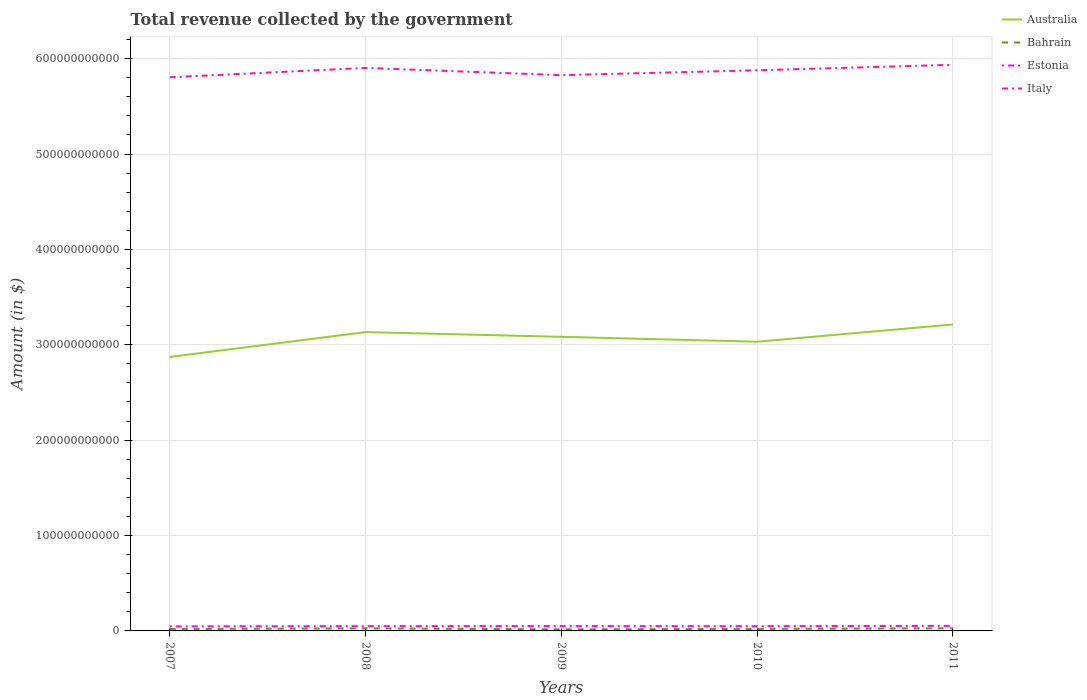Across all years, what is the maximum total revenue collected by the government in Italy?
Offer a very short reply. 5.80e+11. In which year was the total revenue collected by the government in Australia maximum?
Your answer should be compact. 2007. What is the total total revenue collected by the government in Australia in the graph?
Give a very brief answer. -1.60e+1. What is the difference between the highest and the second highest total revenue collected by the government in Estonia?
Keep it short and to the point. 5.53e+08. Is the total revenue collected by the government in Italy strictly greater than the total revenue collected by the government in Estonia over the years?
Provide a succinct answer. No. How many years are there in the graph?
Give a very brief answer. 5. What is the difference between two consecutive major ticks on the Y-axis?
Your response must be concise. 1.00e+11. Are the values on the major ticks of Y-axis written in scientific E-notation?
Provide a short and direct response. No. Does the graph contain grids?
Offer a terse response. Yes. How are the legend labels stacked?
Your answer should be very brief. Vertical. What is the title of the graph?
Your answer should be compact. Total revenue collected by the government. Does "San Marino" appear as one of the legend labels in the graph?
Your answer should be very brief. No. What is the label or title of the Y-axis?
Offer a terse response. Amount (in $). What is the Amount (in $) of Australia in 2007?
Give a very brief answer. 2.87e+11. What is the Amount (in $) of Bahrain in 2007?
Make the answer very short. 2.00e+09. What is the Amount (in $) in Estonia in 2007?
Keep it short and to the point. 4.76e+09. What is the Amount (in $) in Italy in 2007?
Provide a short and direct response. 5.80e+11. What is the Amount (in $) in Australia in 2008?
Make the answer very short. 3.13e+11. What is the Amount (in $) of Bahrain in 2008?
Offer a terse response. 2.65e+09. What is the Amount (in $) of Estonia in 2008?
Your answer should be compact. 4.98e+09. What is the Amount (in $) in Italy in 2008?
Offer a terse response. 5.90e+11. What is the Amount (in $) of Australia in 2009?
Offer a very short reply. 3.08e+11. What is the Amount (in $) of Bahrain in 2009?
Provide a succinct answer. 1.68e+09. What is the Amount (in $) in Estonia in 2009?
Provide a succinct answer. 5.06e+09. What is the Amount (in $) in Italy in 2009?
Your answer should be compact. 5.83e+11. What is the Amount (in $) of Australia in 2010?
Your response must be concise. 3.03e+11. What is the Amount (in $) of Bahrain in 2010?
Your response must be concise. 2.15e+09. What is the Amount (in $) of Estonia in 2010?
Provide a short and direct response. 4.96e+09. What is the Amount (in $) in Italy in 2010?
Offer a very short reply. 5.88e+11. What is the Amount (in $) in Australia in 2011?
Your answer should be compact. 3.21e+11. What is the Amount (in $) of Bahrain in 2011?
Your response must be concise. 2.72e+09. What is the Amount (in $) of Estonia in 2011?
Offer a terse response. 5.31e+09. What is the Amount (in $) of Italy in 2011?
Provide a short and direct response. 5.94e+11. Across all years, what is the maximum Amount (in $) in Australia?
Your response must be concise. 3.21e+11. Across all years, what is the maximum Amount (in $) in Bahrain?
Provide a short and direct response. 2.72e+09. Across all years, what is the maximum Amount (in $) in Estonia?
Your response must be concise. 5.31e+09. Across all years, what is the maximum Amount (in $) of Italy?
Offer a very short reply. 5.94e+11. Across all years, what is the minimum Amount (in $) of Australia?
Make the answer very short. 2.87e+11. Across all years, what is the minimum Amount (in $) in Bahrain?
Your response must be concise. 1.68e+09. Across all years, what is the minimum Amount (in $) of Estonia?
Your response must be concise. 4.76e+09. Across all years, what is the minimum Amount (in $) in Italy?
Offer a very short reply. 5.80e+11. What is the total Amount (in $) in Australia in the graph?
Ensure brevity in your answer.  1.53e+12. What is the total Amount (in $) in Bahrain in the graph?
Give a very brief answer. 1.12e+1. What is the total Amount (in $) in Estonia in the graph?
Provide a succinct answer. 2.51e+1. What is the total Amount (in $) of Italy in the graph?
Your answer should be very brief. 2.93e+12. What is the difference between the Amount (in $) of Australia in 2007 and that in 2008?
Make the answer very short. -2.61e+1. What is the difference between the Amount (in $) in Bahrain in 2007 and that in 2008?
Give a very brief answer. -6.47e+08. What is the difference between the Amount (in $) of Estonia in 2007 and that in 2008?
Give a very brief answer. -2.25e+08. What is the difference between the Amount (in $) of Italy in 2007 and that in 2008?
Your answer should be compact. -9.86e+09. What is the difference between the Amount (in $) of Australia in 2007 and that in 2009?
Ensure brevity in your answer.  -2.12e+1. What is the difference between the Amount (in $) in Bahrain in 2007 and that in 2009?
Make the answer very short. 3.21e+08. What is the difference between the Amount (in $) of Estonia in 2007 and that in 2009?
Your response must be concise. -3.03e+08. What is the difference between the Amount (in $) in Italy in 2007 and that in 2009?
Give a very brief answer. -2.27e+09. What is the difference between the Amount (in $) in Australia in 2007 and that in 2010?
Provide a succinct answer. -1.60e+1. What is the difference between the Amount (in $) in Bahrain in 2007 and that in 2010?
Make the answer very short. -1.46e+08. What is the difference between the Amount (in $) in Estonia in 2007 and that in 2010?
Give a very brief answer. -1.97e+08. What is the difference between the Amount (in $) of Italy in 2007 and that in 2010?
Offer a very short reply. -7.37e+09. What is the difference between the Amount (in $) in Australia in 2007 and that in 2011?
Your response must be concise. -3.41e+1. What is the difference between the Amount (in $) of Bahrain in 2007 and that in 2011?
Keep it short and to the point. -7.18e+08. What is the difference between the Amount (in $) in Estonia in 2007 and that in 2011?
Provide a succinct answer. -5.53e+08. What is the difference between the Amount (in $) in Italy in 2007 and that in 2011?
Provide a succinct answer. -1.31e+1. What is the difference between the Amount (in $) in Australia in 2008 and that in 2009?
Your answer should be compact. 4.94e+09. What is the difference between the Amount (in $) of Bahrain in 2008 and that in 2009?
Your answer should be compact. 9.69e+08. What is the difference between the Amount (in $) in Estonia in 2008 and that in 2009?
Your answer should be compact. -7.78e+07. What is the difference between the Amount (in $) in Italy in 2008 and that in 2009?
Give a very brief answer. 7.59e+09. What is the difference between the Amount (in $) of Australia in 2008 and that in 2010?
Your response must be concise. 1.01e+1. What is the difference between the Amount (in $) in Bahrain in 2008 and that in 2010?
Give a very brief answer. 5.01e+08. What is the difference between the Amount (in $) in Estonia in 2008 and that in 2010?
Provide a succinct answer. 2.82e+07. What is the difference between the Amount (in $) of Italy in 2008 and that in 2010?
Offer a very short reply. 2.49e+09. What is the difference between the Amount (in $) in Australia in 2008 and that in 2011?
Provide a short and direct response. -7.99e+09. What is the difference between the Amount (in $) of Bahrain in 2008 and that in 2011?
Provide a succinct answer. -7.10e+07. What is the difference between the Amount (in $) of Estonia in 2008 and that in 2011?
Make the answer very short. -3.28e+08. What is the difference between the Amount (in $) in Italy in 2008 and that in 2011?
Keep it short and to the point. -3.27e+09. What is the difference between the Amount (in $) of Australia in 2009 and that in 2010?
Make the answer very short. 5.14e+09. What is the difference between the Amount (in $) of Bahrain in 2009 and that in 2010?
Your answer should be compact. -4.67e+08. What is the difference between the Amount (in $) in Estonia in 2009 and that in 2010?
Your answer should be very brief. 1.06e+08. What is the difference between the Amount (in $) in Italy in 2009 and that in 2010?
Your response must be concise. -5.10e+09. What is the difference between the Amount (in $) of Australia in 2009 and that in 2011?
Ensure brevity in your answer.  -1.29e+1. What is the difference between the Amount (in $) in Bahrain in 2009 and that in 2011?
Your response must be concise. -1.04e+09. What is the difference between the Amount (in $) of Estonia in 2009 and that in 2011?
Ensure brevity in your answer.  -2.50e+08. What is the difference between the Amount (in $) of Italy in 2009 and that in 2011?
Offer a terse response. -1.09e+1. What is the difference between the Amount (in $) of Australia in 2010 and that in 2011?
Offer a terse response. -1.81e+1. What is the difference between the Amount (in $) in Bahrain in 2010 and that in 2011?
Your response must be concise. -5.72e+08. What is the difference between the Amount (in $) in Estonia in 2010 and that in 2011?
Keep it short and to the point. -3.56e+08. What is the difference between the Amount (in $) of Italy in 2010 and that in 2011?
Offer a very short reply. -5.75e+09. What is the difference between the Amount (in $) in Australia in 2007 and the Amount (in $) in Bahrain in 2008?
Your answer should be very brief. 2.85e+11. What is the difference between the Amount (in $) in Australia in 2007 and the Amount (in $) in Estonia in 2008?
Provide a short and direct response. 2.82e+11. What is the difference between the Amount (in $) of Australia in 2007 and the Amount (in $) of Italy in 2008?
Keep it short and to the point. -3.03e+11. What is the difference between the Amount (in $) of Bahrain in 2007 and the Amount (in $) of Estonia in 2008?
Your response must be concise. -2.98e+09. What is the difference between the Amount (in $) in Bahrain in 2007 and the Amount (in $) in Italy in 2008?
Provide a succinct answer. -5.88e+11. What is the difference between the Amount (in $) in Estonia in 2007 and the Amount (in $) in Italy in 2008?
Give a very brief answer. -5.85e+11. What is the difference between the Amount (in $) of Australia in 2007 and the Amount (in $) of Bahrain in 2009?
Offer a very short reply. 2.86e+11. What is the difference between the Amount (in $) of Australia in 2007 and the Amount (in $) of Estonia in 2009?
Provide a short and direct response. 2.82e+11. What is the difference between the Amount (in $) of Australia in 2007 and the Amount (in $) of Italy in 2009?
Give a very brief answer. -2.95e+11. What is the difference between the Amount (in $) of Bahrain in 2007 and the Amount (in $) of Estonia in 2009?
Your answer should be compact. -3.06e+09. What is the difference between the Amount (in $) of Bahrain in 2007 and the Amount (in $) of Italy in 2009?
Your answer should be compact. -5.81e+11. What is the difference between the Amount (in $) in Estonia in 2007 and the Amount (in $) in Italy in 2009?
Your answer should be compact. -5.78e+11. What is the difference between the Amount (in $) of Australia in 2007 and the Amount (in $) of Bahrain in 2010?
Your response must be concise. 2.85e+11. What is the difference between the Amount (in $) of Australia in 2007 and the Amount (in $) of Estonia in 2010?
Your answer should be very brief. 2.82e+11. What is the difference between the Amount (in $) of Australia in 2007 and the Amount (in $) of Italy in 2010?
Provide a succinct answer. -3.01e+11. What is the difference between the Amount (in $) in Bahrain in 2007 and the Amount (in $) in Estonia in 2010?
Your answer should be very brief. -2.96e+09. What is the difference between the Amount (in $) of Bahrain in 2007 and the Amount (in $) of Italy in 2010?
Keep it short and to the point. -5.86e+11. What is the difference between the Amount (in $) in Estonia in 2007 and the Amount (in $) in Italy in 2010?
Keep it short and to the point. -5.83e+11. What is the difference between the Amount (in $) in Australia in 2007 and the Amount (in $) in Bahrain in 2011?
Your answer should be compact. 2.84e+11. What is the difference between the Amount (in $) in Australia in 2007 and the Amount (in $) in Estonia in 2011?
Keep it short and to the point. 2.82e+11. What is the difference between the Amount (in $) of Australia in 2007 and the Amount (in $) of Italy in 2011?
Your answer should be compact. -3.06e+11. What is the difference between the Amount (in $) of Bahrain in 2007 and the Amount (in $) of Estonia in 2011?
Your response must be concise. -3.31e+09. What is the difference between the Amount (in $) of Bahrain in 2007 and the Amount (in $) of Italy in 2011?
Offer a very short reply. -5.92e+11. What is the difference between the Amount (in $) of Estonia in 2007 and the Amount (in $) of Italy in 2011?
Your response must be concise. -5.89e+11. What is the difference between the Amount (in $) of Australia in 2008 and the Amount (in $) of Bahrain in 2009?
Your response must be concise. 3.12e+11. What is the difference between the Amount (in $) in Australia in 2008 and the Amount (in $) in Estonia in 2009?
Keep it short and to the point. 3.08e+11. What is the difference between the Amount (in $) of Australia in 2008 and the Amount (in $) of Italy in 2009?
Make the answer very short. -2.69e+11. What is the difference between the Amount (in $) in Bahrain in 2008 and the Amount (in $) in Estonia in 2009?
Give a very brief answer. -2.41e+09. What is the difference between the Amount (in $) of Bahrain in 2008 and the Amount (in $) of Italy in 2009?
Make the answer very short. -5.80e+11. What is the difference between the Amount (in $) of Estonia in 2008 and the Amount (in $) of Italy in 2009?
Give a very brief answer. -5.78e+11. What is the difference between the Amount (in $) of Australia in 2008 and the Amount (in $) of Bahrain in 2010?
Your response must be concise. 3.11e+11. What is the difference between the Amount (in $) in Australia in 2008 and the Amount (in $) in Estonia in 2010?
Keep it short and to the point. 3.08e+11. What is the difference between the Amount (in $) in Australia in 2008 and the Amount (in $) in Italy in 2010?
Offer a terse response. -2.74e+11. What is the difference between the Amount (in $) of Bahrain in 2008 and the Amount (in $) of Estonia in 2010?
Ensure brevity in your answer.  -2.31e+09. What is the difference between the Amount (in $) of Bahrain in 2008 and the Amount (in $) of Italy in 2010?
Keep it short and to the point. -5.85e+11. What is the difference between the Amount (in $) of Estonia in 2008 and the Amount (in $) of Italy in 2010?
Make the answer very short. -5.83e+11. What is the difference between the Amount (in $) of Australia in 2008 and the Amount (in $) of Bahrain in 2011?
Give a very brief answer. 3.11e+11. What is the difference between the Amount (in $) of Australia in 2008 and the Amount (in $) of Estonia in 2011?
Offer a very short reply. 3.08e+11. What is the difference between the Amount (in $) of Australia in 2008 and the Amount (in $) of Italy in 2011?
Provide a short and direct response. -2.80e+11. What is the difference between the Amount (in $) in Bahrain in 2008 and the Amount (in $) in Estonia in 2011?
Ensure brevity in your answer.  -2.66e+09. What is the difference between the Amount (in $) of Bahrain in 2008 and the Amount (in $) of Italy in 2011?
Your answer should be compact. -5.91e+11. What is the difference between the Amount (in $) of Estonia in 2008 and the Amount (in $) of Italy in 2011?
Provide a succinct answer. -5.89e+11. What is the difference between the Amount (in $) of Australia in 2009 and the Amount (in $) of Bahrain in 2010?
Your response must be concise. 3.06e+11. What is the difference between the Amount (in $) of Australia in 2009 and the Amount (in $) of Estonia in 2010?
Provide a succinct answer. 3.03e+11. What is the difference between the Amount (in $) in Australia in 2009 and the Amount (in $) in Italy in 2010?
Your response must be concise. -2.79e+11. What is the difference between the Amount (in $) in Bahrain in 2009 and the Amount (in $) in Estonia in 2010?
Keep it short and to the point. -3.28e+09. What is the difference between the Amount (in $) of Bahrain in 2009 and the Amount (in $) of Italy in 2010?
Ensure brevity in your answer.  -5.86e+11. What is the difference between the Amount (in $) in Estonia in 2009 and the Amount (in $) in Italy in 2010?
Make the answer very short. -5.83e+11. What is the difference between the Amount (in $) of Australia in 2009 and the Amount (in $) of Bahrain in 2011?
Ensure brevity in your answer.  3.06e+11. What is the difference between the Amount (in $) in Australia in 2009 and the Amount (in $) in Estonia in 2011?
Give a very brief answer. 3.03e+11. What is the difference between the Amount (in $) in Australia in 2009 and the Amount (in $) in Italy in 2011?
Your answer should be compact. -2.85e+11. What is the difference between the Amount (in $) in Bahrain in 2009 and the Amount (in $) in Estonia in 2011?
Offer a very short reply. -3.63e+09. What is the difference between the Amount (in $) in Bahrain in 2009 and the Amount (in $) in Italy in 2011?
Provide a short and direct response. -5.92e+11. What is the difference between the Amount (in $) of Estonia in 2009 and the Amount (in $) of Italy in 2011?
Give a very brief answer. -5.88e+11. What is the difference between the Amount (in $) of Australia in 2010 and the Amount (in $) of Bahrain in 2011?
Give a very brief answer. 3.00e+11. What is the difference between the Amount (in $) of Australia in 2010 and the Amount (in $) of Estonia in 2011?
Provide a short and direct response. 2.98e+11. What is the difference between the Amount (in $) of Australia in 2010 and the Amount (in $) of Italy in 2011?
Ensure brevity in your answer.  -2.90e+11. What is the difference between the Amount (in $) in Bahrain in 2010 and the Amount (in $) in Estonia in 2011?
Provide a short and direct response. -3.17e+09. What is the difference between the Amount (in $) of Bahrain in 2010 and the Amount (in $) of Italy in 2011?
Your response must be concise. -5.91e+11. What is the difference between the Amount (in $) of Estonia in 2010 and the Amount (in $) of Italy in 2011?
Provide a succinct answer. -5.89e+11. What is the average Amount (in $) in Australia per year?
Your response must be concise. 3.07e+11. What is the average Amount (in $) of Bahrain per year?
Make the answer very short. 2.24e+09. What is the average Amount (in $) in Estonia per year?
Keep it short and to the point. 5.02e+09. What is the average Amount (in $) in Italy per year?
Your answer should be compact. 5.87e+11. In the year 2007, what is the difference between the Amount (in $) of Australia and Amount (in $) of Bahrain?
Make the answer very short. 2.85e+11. In the year 2007, what is the difference between the Amount (in $) of Australia and Amount (in $) of Estonia?
Your answer should be very brief. 2.82e+11. In the year 2007, what is the difference between the Amount (in $) in Australia and Amount (in $) in Italy?
Ensure brevity in your answer.  -2.93e+11. In the year 2007, what is the difference between the Amount (in $) of Bahrain and Amount (in $) of Estonia?
Provide a short and direct response. -2.76e+09. In the year 2007, what is the difference between the Amount (in $) of Bahrain and Amount (in $) of Italy?
Your response must be concise. -5.78e+11. In the year 2007, what is the difference between the Amount (in $) of Estonia and Amount (in $) of Italy?
Offer a very short reply. -5.76e+11. In the year 2008, what is the difference between the Amount (in $) in Australia and Amount (in $) in Bahrain?
Offer a very short reply. 3.11e+11. In the year 2008, what is the difference between the Amount (in $) of Australia and Amount (in $) of Estonia?
Give a very brief answer. 3.08e+11. In the year 2008, what is the difference between the Amount (in $) in Australia and Amount (in $) in Italy?
Make the answer very short. -2.77e+11. In the year 2008, what is the difference between the Amount (in $) of Bahrain and Amount (in $) of Estonia?
Provide a short and direct response. -2.34e+09. In the year 2008, what is the difference between the Amount (in $) in Bahrain and Amount (in $) in Italy?
Your answer should be very brief. -5.88e+11. In the year 2008, what is the difference between the Amount (in $) in Estonia and Amount (in $) in Italy?
Your response must be concise. -5.85e+11. In the year 2009, what is the difference between the Amount (in $) in Australia and Amount (in $) in Bahrain?
Provide a succinct answer. 3.07e+11. In the year 2009, what is the difference between the Amount (in $) in Australia and Amount (in $) in Estonia?
Offer a very short reply. 3.03e+11. In the year 2009, what is the difference between the Amount (in $) in Australia and Amount (in $) in Italy?
Your answer should be very brief. -2.74e+11. In the year 2009, what is the difference between the Amount (in $) of Bahrain and Amount (in $) of Estonia?
Keep it short and to the point. -3.38e+09. In the year 2009, what is the difference between the Amount (in $) of Bahrain and Amount (in $) of Italy?
Offer a terse response. -5.81e+11. In the year 2009, what is the difference between the Amount (in $) of Estonia and Amount (in $) of Italy?
Keep it short and to the point. -5.78e+11. In the year 2010, what is the difference between the Amount (in $) of Australia and Amount (in $) of Bahrain?
Your answer should be very brief. 3.01e+11. In the year 2010, what is the difference between the Amount (in $) of Australia and Amount (in $) of Estonia?
Provide a succinct answer. 2.98e+11. In the year 2010, what is the difference between the Amount (in $) in Australia and Amount (in $) in Italy?
Offer a very short reply. -2.85e+11. In the year 2010, what is the difference between the Amount (in $) in Bahrain and Amount (in $) in Estonia?
Provide a succinct answer. -2.81e+09. In the year 2010, what is the difference between the Amount (in $) of Bahrain and Amount (in $) of Italy?
Provide a short and direct response. -5.86e+11. In the year 2010, what is the difference between the Amount (in $) in Estonia and Amount (in $) in Italy?
Offer a terse response. -5.83e+11. In the year 2011, what is the difference between the Amount (in $) of Australia and Amount (in $) of Bahrain?
Provide a succinct answer. 3.19e+11. In the year 2011, what is the difference between the Amount (in $) in Australia and Amount (in $) in Estonia?
Give a very brief answer. 3.16e+11. In the year 2011, what is the difference between the Amount (in $) in Australia and Amount (in $) in Italy?
Offer a terse response. -2.72e+11. In the year 2011, what is the difference between the Amount (in $) in Bahrain and Amount (in $) in Estonia?
Your answer should be compact. -2.59e+09. In the year 2011, what is the difference between the Amount (in $) in Bahrain and Amount (in $) in Italy?
Ensure brevity in your answer.  -5.91e+11. In the year 2011, what is the difference between the Amount (in $) in Estonia and Amount (in $) in Italy?
Offer a terse response. -5.88e+11. What is the ratio of the Amount (in $) in Australia in 2007 to that in 2008?
Give a very brief answer. 0.92. What is the ratio of the Amount (in $) of Bahrain in 2007 to that in 2008?
Your answer should be very brief. 0.76. What is the ratio of the Amount (in $) in Estonia in 2007 to that in 2008?
Ensure brevity in your answer.  0.95. What is the ratio of the Amount (in $) in Italy in 2007 to that in 2008?
Your answer should be compact. 0.98. What is the ratio of the Amount (in $) of Australia in 2007 to that in 2009?
Offer a very short reply. 0.93. What is the ratio of the Amount (in $) in Bahrain in 2007 to that in 2009?
Provide a short and direct response. 1.19. What is the ratio of the Amount (in $) in Estonia in 2007 to that in 2009?
Provide a short and direct response. 0.94. What is the ratio of the Amount (in $) in Australia in 2007 to that in 2010?
Keep it short and to the point. 0.95. What is the ratio of the Amount (in $) in Bahrain in 2007 to that in 2010?
Keep it short and to the point. 0.93. What is the ratio of the Amount (in $) in Estonia in 2007 to that in 2010?
Ensure brevity in your answer.  0.96. What is the ratio of the Amount (in $) in Italy in 2007 to that in 2010?
Keep it short and to the point. 0.99. What is the ratio of the Amount (in $) in Australia in 2007 to that in 2011?
Provide a succinct answer. 0.89. What is the ratio of the Amount (in $) in Bahrain in 2007 to that in 2011?
Your answer should be very brief. 0.74. What is the ratio of the Amount (in $) in Estonia in 2007 to that in 2011?
Your answer should be very brief. 0.9. What is the ratio of the Amount (in $) of Italy in 2007 to that in 2011?
Ensure brevity in your answer.  0.98. What is the ratio of the Amount (in $) of Australia in 2008 to that in 2009?
Keep it short and to the point. 1.02. What is the ratio of the Amount (in $) in Bahrain in 2008 to that in 2009?
Your answer should be compact. 1.58. What is the ratio of the Amount (in $) in Estonia in 2008 to that in 2009?
Offer a very short reply. 0.98. What is the ratio of the Amount (in $) in Italy in 2008 to that in 2009?
Make the answer very short. 1.01. What is the ratio of the Amount (in $) in Australia in 2008 to that in 2010?
Offer a terse response. 1.03. What is the ratio of the Amount (in $) in Bahrain in 2008 to that in 2010?
Provide a short and direct response. 1.23. What is the ratio of the Amount (in $) of Australia in 2008 to that in 2011?
Provide a short and direct response. 0.98. What is the ratio of the Amount (in $) in Bahrain in 2008 to that in 2011?
Offer a terse response. 0.97. What is the ratio of the Amount (in $) in Estonia in 2008 to that in 2011?
Keep it short and to the point. 0.94. What is the ratio of the Amount (in $) in Australia in 2009 to that in 2010?
Your response must be concise. 1.02. What is the ratio of the Amount (in $) of Bahrain in 2009 to that in 2010?
Provide a succinct answer. 0.78. What is the ratio of the Amount (in $) in Estonia in 2009 to that in 2010?
Keep it short and to the point. 1.02. What is the ratio of the Amount (in $) in Italy in 2009 to that in 2010?
Provide a short and direct response. 0.99. What is the ratio of the Amount (in $) of Australia in 2009 to that in 2011?
Give a very brief answer. 0.96. What is the ratio of the Amount (in $) in Bahrain in 2009 to that in 2011?
Keep it short and to the point. 0.62. What is the ratio of the Amount (in $) in Estonia in 2009 to that in 2011?
Provide a succinct answer. 0.95. What is the ratio of the Amount (in $) of Italy in 2009 to that in 2011?
Provide a short and direct response. 0.98. What is the ratio of the Amount (in $) of Australia in 2010 to that in 2011?
Your answer should be very brief. 0.94. What is the ratio of the Amount (in $) in Bahrain in 2010 to that in 2011?
Offer a very short reply. 0.79. What is the ratio of the Amount (in $) in Estonia in 2010 to that in 2011?
Your answer should be very brief. 0.93. What is the ratio of the Amount (in $) in Italy in 2010 to that in 2011?
Your response must be concise. 0.99. What is the difference between the highest and the second highest Amount (in $) in Australia?
Provide a succinct answer. 7.99e+09. What is the difference between the highest and the second highest Amount (in $) in Bahrain?
Provide a short and direct response. 7.10e+07. What is the difference between the highest and the second highest Amount (in $) of Estonia?
Provide a succinct answer. 2.50e+08. What is the difference between the highest and the second highest Amount (in $) in Italy?
Your response must be concise. 3.27e+09. What is the difference between the highest and the lowest Amount (in $) in Australia?
Ensure brevity in your answer.  3.41e+1. What is the difference between the highest and the lowest Amount (in $) of Bahrain?
Your answer should be very brief. 1.04e+09. What is the difference between the highest and the lowest Amount (in $) of Estonia?
Your answer should be very brief. 5.53e+08. What is the difference between the highest and the lowest Amount (in $) of Italy?
Your response must be concise. 1.31e+1. 